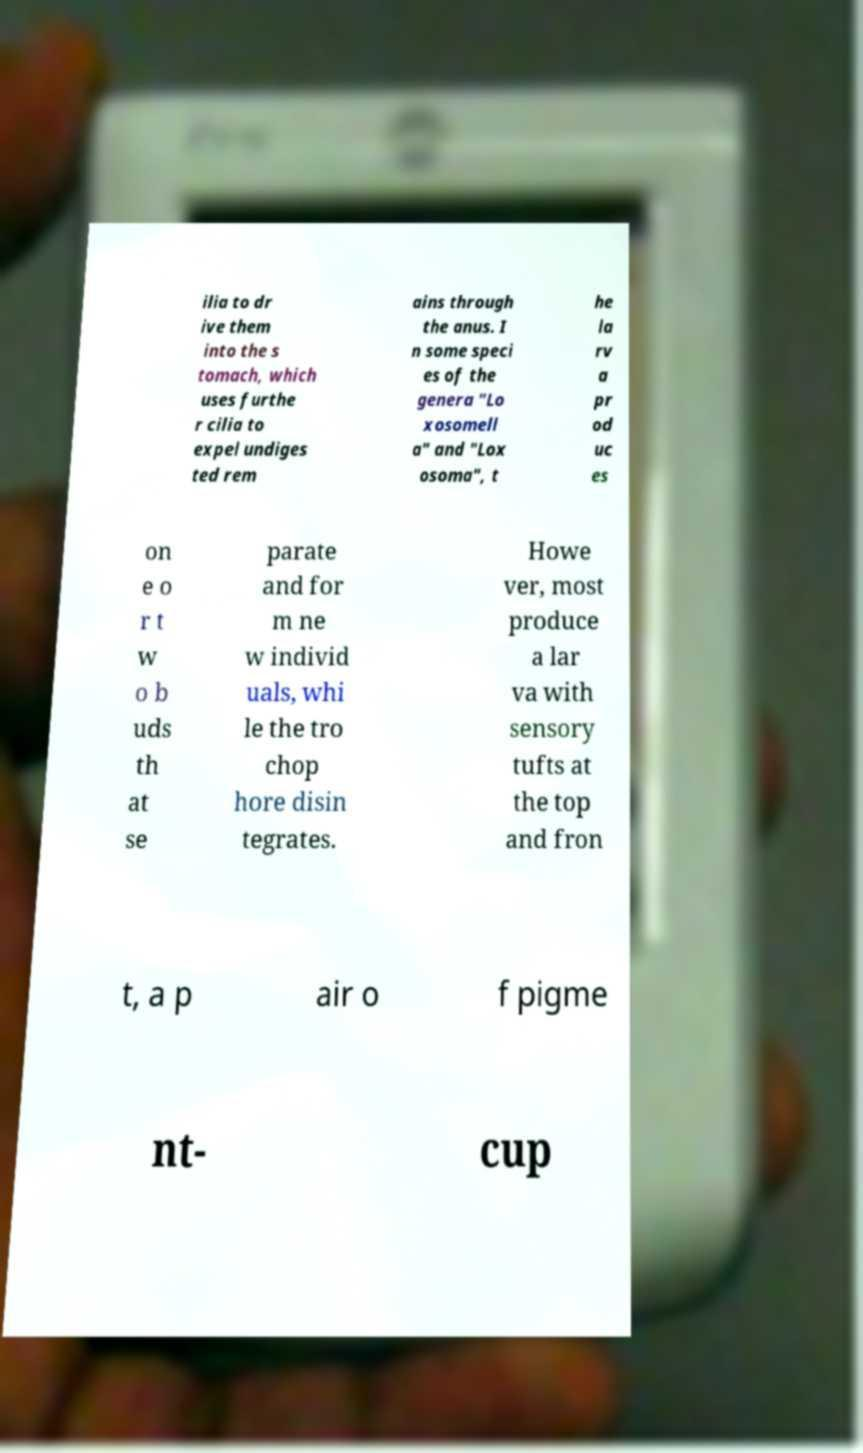Could you assist in decoding the text presented in this image and type it out clearly? ilia to dr ive them into the s tomach, which uses furthe r cilia to expel undiges ted rem ains through the anus. I n some speci es of the genera "Lo xosomell a" and "Lox osoma", t he la rv a pr od uc es on e o r t w o b uds th at se parate and for m ne w individ uals, whi le the tro chop hore disin tegrates. Howe ver, most produce a lar va with sensory tufts at the top and fron t, a p air o f pigme nt- cup 